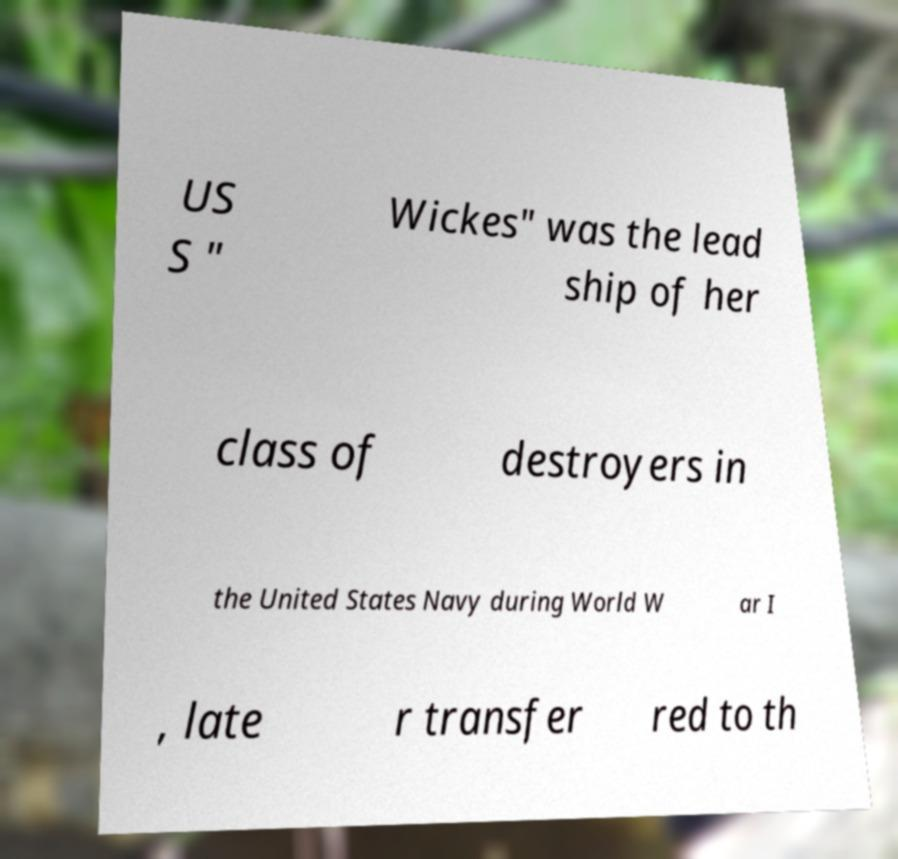What messages or text are displayed in this image? I need them in a readable, typed format. US S " Wickes" was the lead ship of her class of destroyers in the United States Navy during World W ar I , late r transfer red to th 